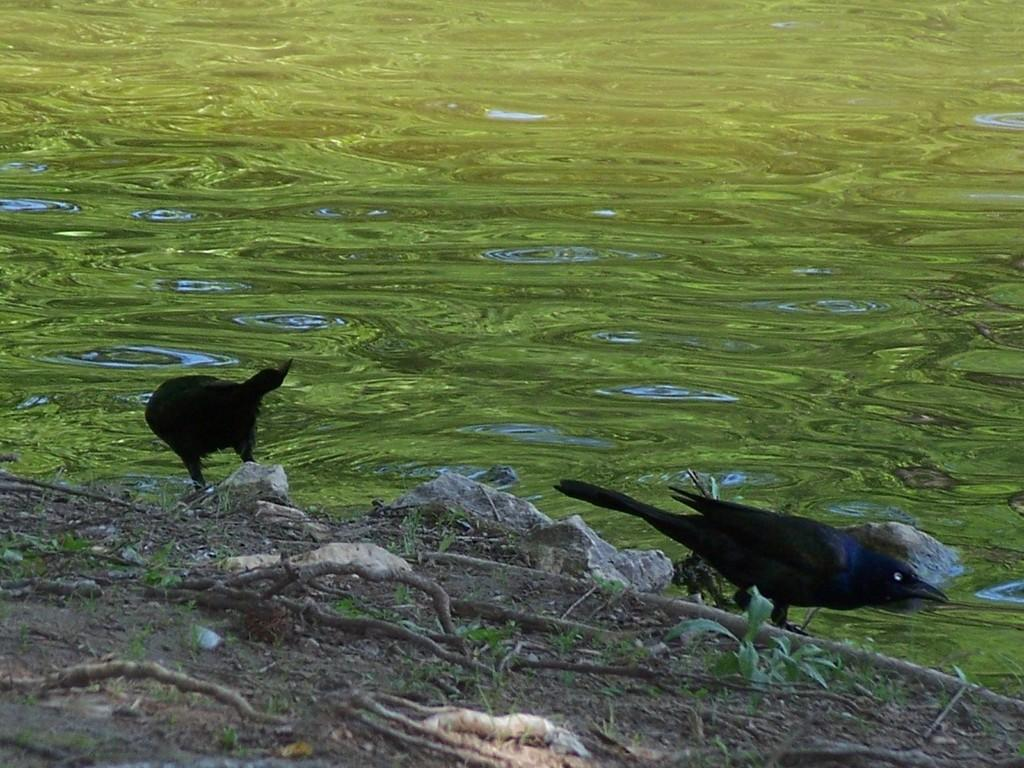What is on the surface that can be seen in the image? There are twigs and rocks on the surface in the image. What type of animals are present in the image? There are two black birds in the image. Where are the birds located in relation to the surface? The birds are standing near the surface. What else is visible in the image besides the surface and the birds? There is water visible beside the surface. Can you tell me how many kittens are playing with the twig in the image? There are no kittens present in the image; it features two black birds and a surface with twigs and rocks. Is there a police officer visible in the image? There is no police officer present in the image. 